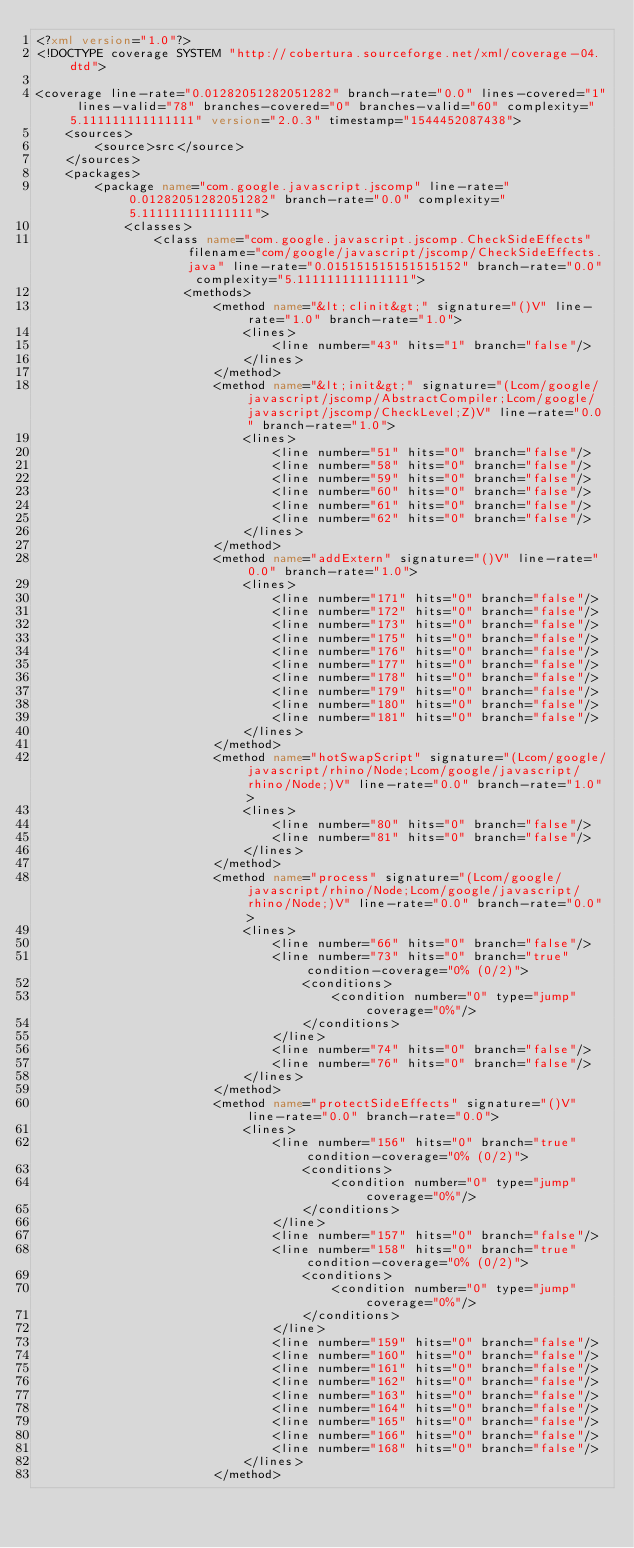<code> <loc_0><loc_0><loc_500><loc_500><_XML_><?xml version="1.0"?>
<!DOCTYPE coverage SYSTEM "http://cobertura.sourceforge.net/xml/coverage-04.dtd">

<coverage line-rate="0.01282051282051282" branch-rate="0.0" lines-covered="1" lines-valid="78" branches-covered="0" branches-valid="60" complexity="5.111111111111111" version="2.0.3" timestamp="1544452087438">
	<sources>
		<source>src</source>
	</sources>
	<packages>
		<package name="com.google.javascript.jscomp" line-rate="0.01282051282051282" branch-rate="0.0" complexity="5.111111111111111">
			<classes>
				<class name="com.google.javascript.jscomp.CheckSideEffects" filename="com/google/javascript/jscomp/CheckSideEffects.java" line-rate="0.015151515151515152" branch-rate="0.0" complexity="5.111111111111111">
					<methods>
						<method name="&lt;clinit&gt;" signature="()V" line-rate="1.0" branch-rate="1.0">
							<lines>
								<line number="43" hits="1" branch="false"/>
							</lines>
						</method>
						<method name="&lt;init&gt;" signature="(Lcom/google/javascript/jscomp/AbstractCompiler;Lcom/google/javascript/jscomp/CheckLevel;Z)V" line-rate="0.0" branch-rate="1.0">
							<lines>
								<line number="51" hits="0" branch="false"/>
								<line number="58" hits="0" branch="false"/>
								<line number="59" hits="0" branch="false"/>
								<line number="60" hits="0" branch="false"/>
								<line number="61" hits="0" branch="false"/>
								<line number="62" hits="0" branch="false"/>
							</lines>
						</method>
						<method name="addExtern" signature="()V" line-rate="0.0" branch-rate="1.0">
							<lines>
								<line number="171" hits="0" branch="false"/>
								<line number="172" hits="0" branch="false"/>
								<line number="173" hits="0" branch="false"/>
								<line number="175" hits="0" branch="false"/>
								<line number="176" hits="0" branch="false"/>
								<line number="177" hits="0" branch="false"/>
								<line number="178" hits="0" branch="false"/>
								<line number="179" hits="0" branch="false"/>
								<line number="180" hits="0" branch="false"/>
								<line number="181" hits="0" branch="false"/>
							</lines>
						</method>
						<method name="hotSwapScript" signature="(Lcom/google/javascript/rhino/Node;Lcom/google/javascript/rhino/Node;)V" line-rate="0.0" branch-rate="1.0">
							<lines>
								<line number="80" hits="0" branch="false"/>
								<line number="81" hits="0" branch="false"/>
							</lines>
						</method>
						<method name="process" signature="(Lcom/google/javascript/rhino/Node;Lcom/google/javascript/rhino/Node;)V" line-rate="0.0" branch-rate="0.0">
							<lines>
								<line number="66" hits="0" branch="false"/>
								<line number="73" hits="0" branch="true" condition-coverage="0% (0/2)">
									<conditions>
										<condition number="0" type="jump" coverage="0%"/>
									</conditions>
								</line>
								<line number="74" hits="0" branch="false"/>
								<line number="76" hits="0" branch="false"/>
							</lines>
						</method>
						<method name="protectSideEffects" signature="()V" line-rate="0.0" branch-rate="0.0">
							<lines>
								<line number="156" hits="0" branch="true" condition-coverage="0% (0/2)">
									<conditions>
										<condition number="0" type="jump" coverage="0%"/>
									</conditions>
								</line>
								<line number="157" hits="0" branch="false"/>
								<line number="158" hits="0" branch="true" condition-coverage="0% (0/2)">
									<conditions>
										<condition number="0" type="jump" coverage="0%"/>
									</conditions>
								</line>
								<line number="159" hits="0" branch="false"/>
								<line number="160" hits="0" branch="false"/>
								<line number="161" hits="0" branch="false"/>
								<line number="162" hits="0" branch="false"/>
								<line number="163" hits="0" branch="false"/>
								<line number="164" hits="0" branch="false"/>
								<line number="165" hits="0" branch="false"/>
								<line number="166" hits="0" branch="false"/>
								<line number="168" hits="0" branch="false"/>
							</lines>
						</method></code> 